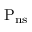Convert formula to latex. <formula><loc_0><loc_0><loc_500><loc_500>{ { P _ { n s } } }</formula> 